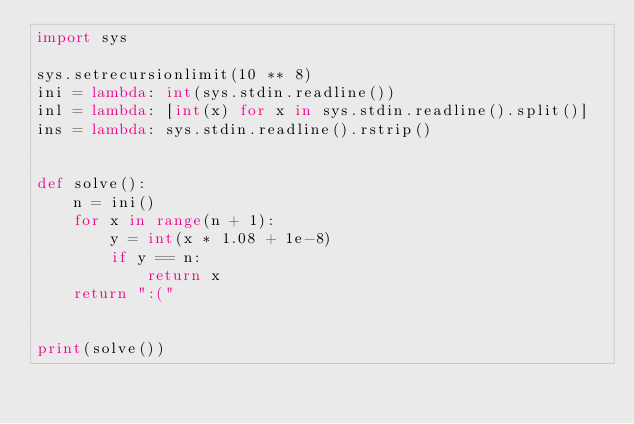Convert code to text. <code><loc_0><loc_0><loc_500><loc_500><_Python_>import sys

sys.setrecursionlimit(10 ** 8)
ini = lambda: int(sys.stdin.readline())
inl = lambda: [int(x) for x in sys.stdin.readline().split()]
ins = lambda: sys.stdin.readline().rstrip()


def solve():
    n = ini()
    for x in range(n + 1):
        y = int(x * 1.08 + 1e-8)
        if y == n:
            return x
    return ":("


print(solve())
</code> 